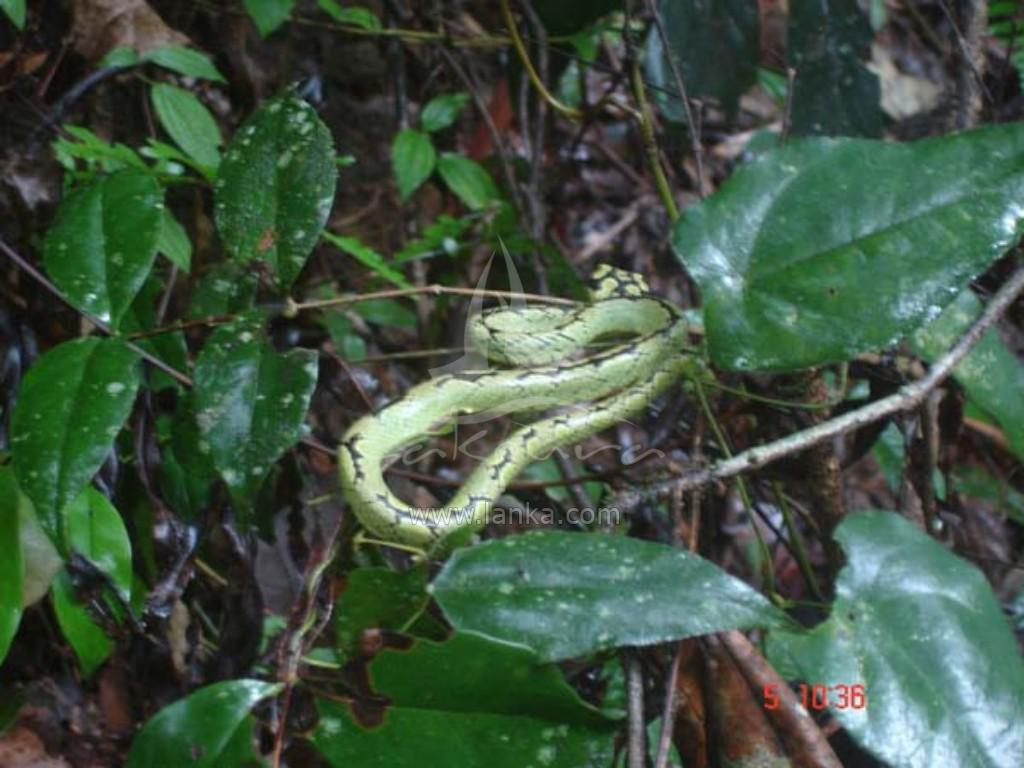What type of living organisms can be seen in the image? Plants can be seen in the image. Are there any animals present in the image? Yes, there is a snake in the image. What type of oatmeal is the snake eating in the image? There is no oatmeal present in the image; the snake is not shown eating anything. 